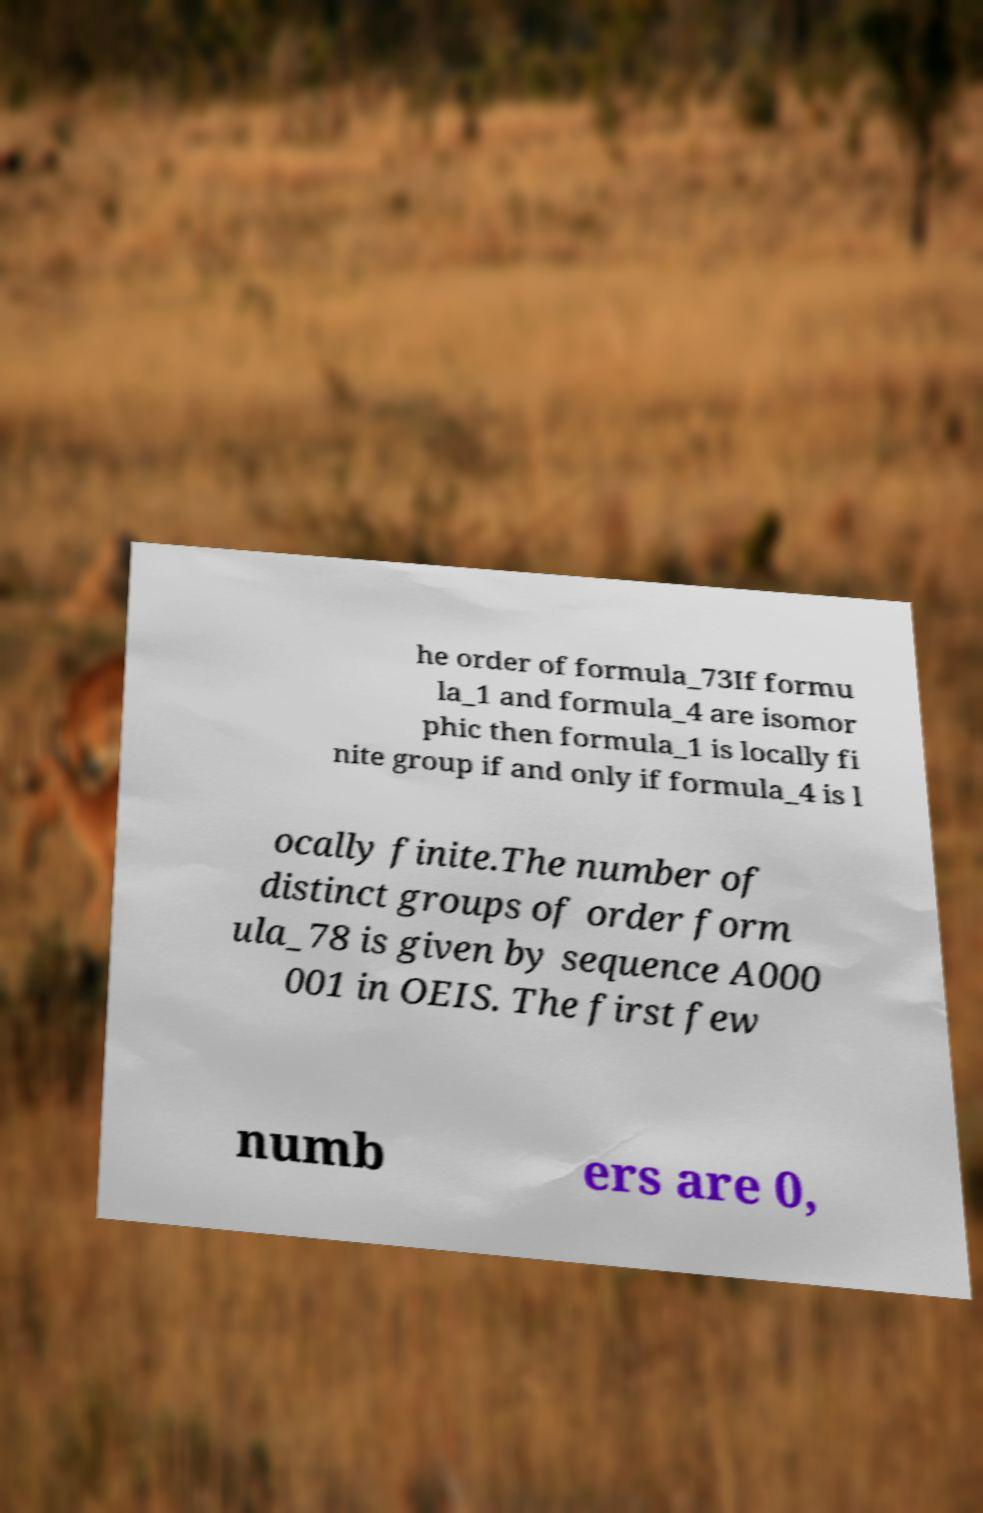Please read and relay the text visible in this image. What does it say? he order of formula_73If formu la_1 and formula_4 are isomor phic then formula_1 is locally fi nite group if and only if formula_4 is l ocally finite.The number of distinct groups of order form ula_78 is given by sequence A000 001 in OEIS. The first few numb ers are 0, 